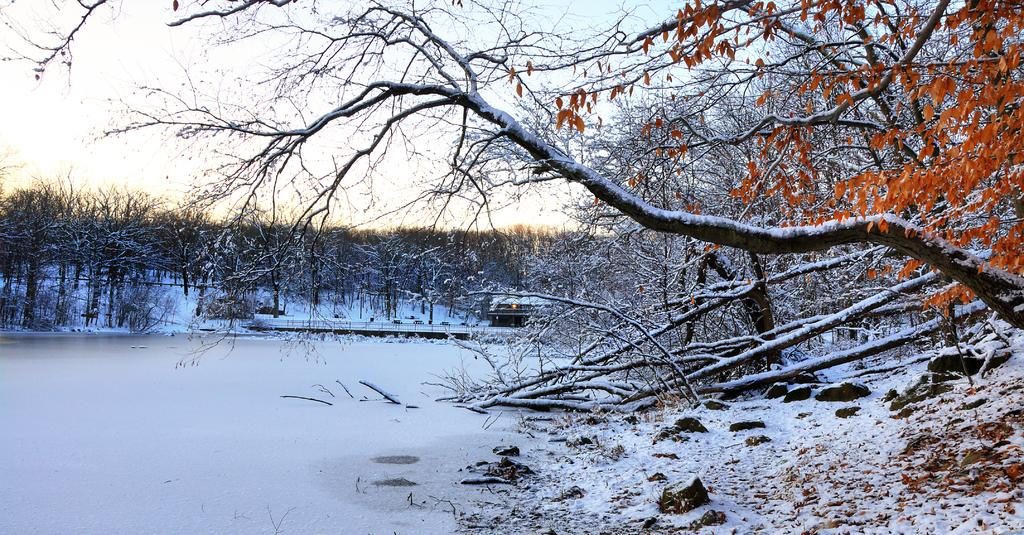What type of vegetation is present in the image? There are trees with leaves in the image. How is the vegetation affected by the weather in the image? The leaves are partially covered with snow, indicating a snowy scene. What other elements can be seen in the image? There are rocks visible in the image. How does the image depict the wealth of the family? The image does not depict the wealth of a family; it shows a snowy scene with trees, leaves, and rocks. 